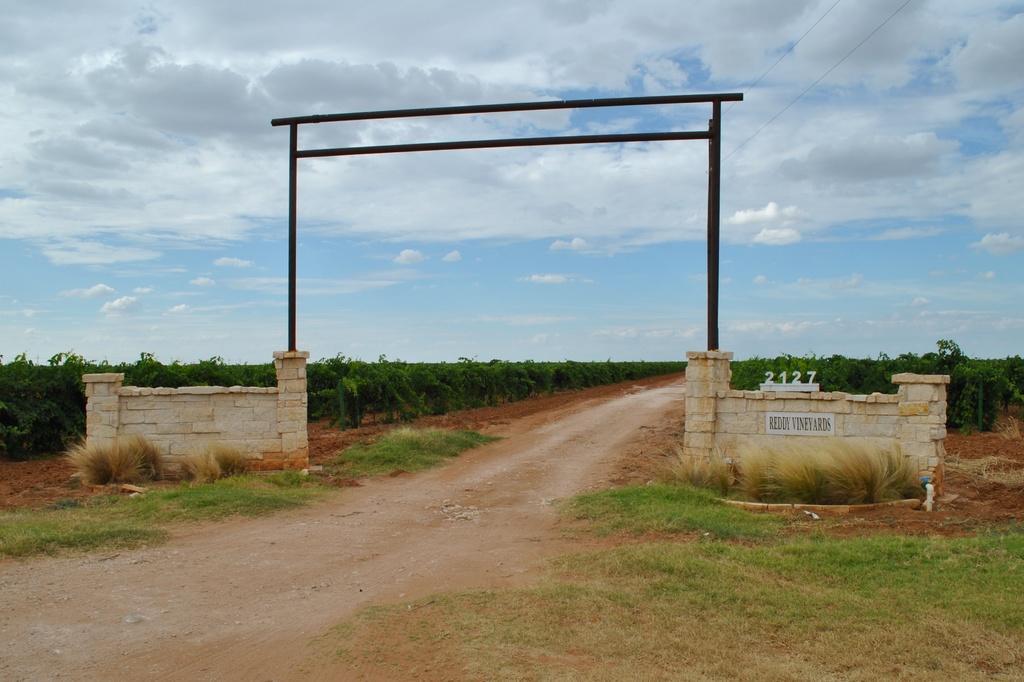Could you give a brief overview of what you see in this image? In the image there is arch on a wall, in the middle there is path, on either side of it there are plants on the land and above its sky with clouds. 